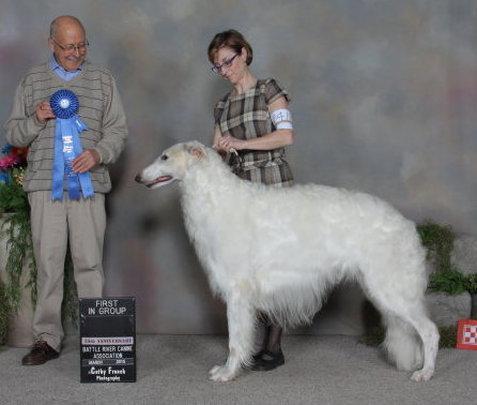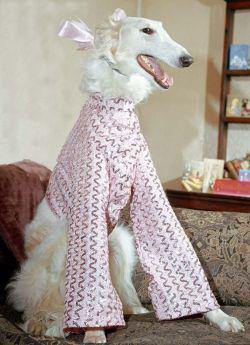The first image is the image on the left, the second image is the image on the right. For the images shown, is this caption "there is a female sitting with a dog in one of the images" true? Answer yes or no. No. The first image is the image on the left, the second image is the image on the right. For the images displayed, is the sentence "There are at least two white dogs in the right image." factually correct? Answer yes or no. No. 